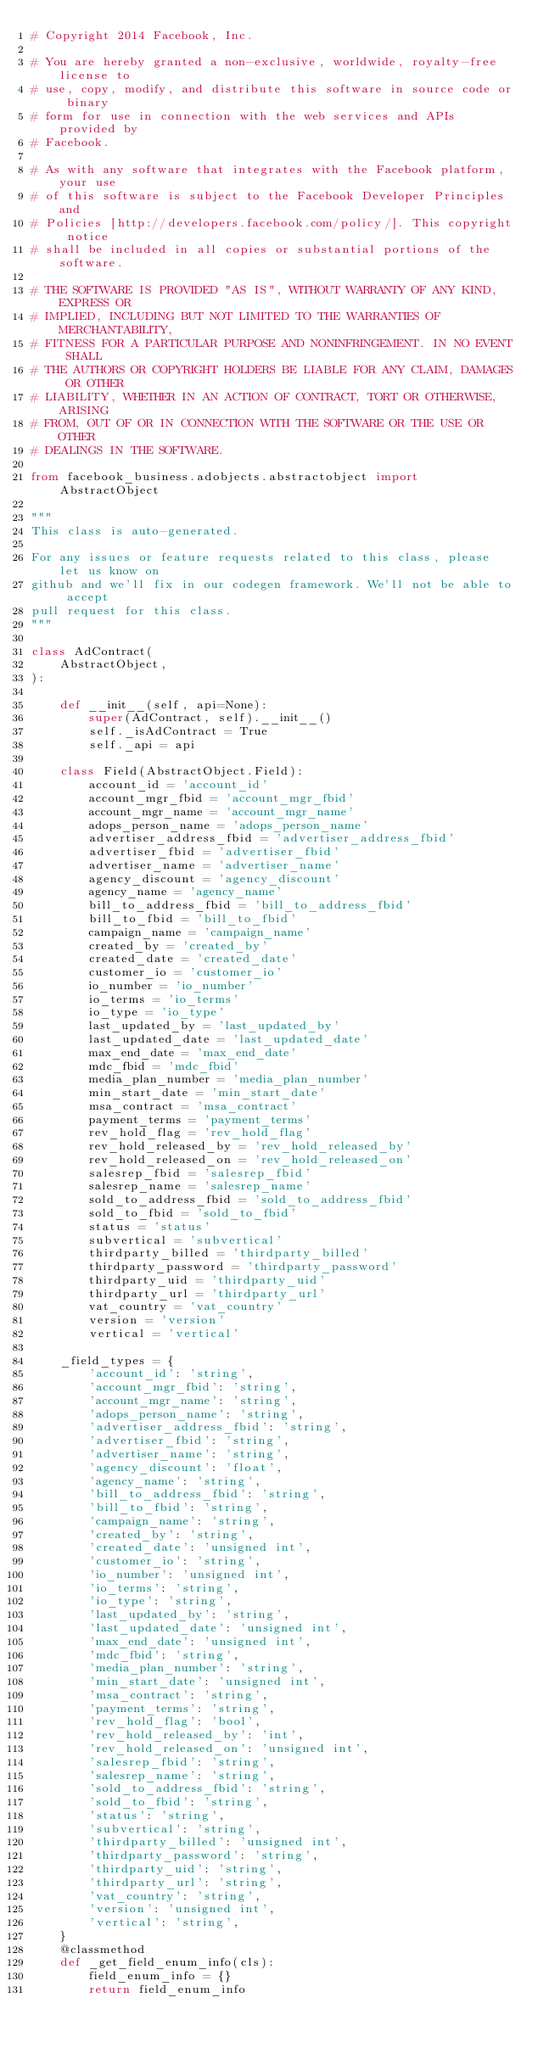Convert code to text. <code><loc_0><loc_0><loc_500><loc_500><_Python_># Copyright 2014 Facebook, Inc.

# You are hereby granted a non-exclusive, worldwide, royalty-free license to
# use, copy, modify, and distribute this software in source code or binary
# form for use in connection with the web services and APIs provided by
# Facebook.

# As with any software that integrates with the Facebook platform, your use
# of this software is subject to the Facebook Developer Principles and
# Policies [http://developers.facebook.com/policy/]. This copyright notice
# shall be included in all copies or substantial portions of the software.

# THE SOFTWARE IS PROVIDED "AS IS", WITHOUT WARRANTY OF ANY KIND, EXPRESS OR
# IMPLIED, INCLUDING BUT NOT LIMITED TO THE WARRANTIES OF MERCHANTABILITY,
# FITNESS FOR A PARTICULAR PURPOSE AND NONINFRINGEMENT. IN NO EVENT SHALL
# THE AUTHORS OR COPYRIGHT HOLDERS BE LIABLE FOR ANY CLAIM, DAMAGES OR OTHER
# LIABILITY, WHETHER IN AN ACTION OF CONTRACT, TORT OR OTHERWISE, ARISING
# FROM, OUT OF OR IN CONNECTION WITH THE SOFTWARE OR THE USE OR OTHER
# DEALINGS IN THE SOFTWARE.

from facebook_business.adobjects.abstractobject import AbstractObject

"""
This class is auto-generated.

For any issues or feature requests related to this class, please let us know on
github and we'll fix in our codegen framework. We'll not be able to accept
pull request for this class.
"""

class AdContract(
    AbstractObject,
):

    def __init__(self, api=None):
        super(AdContract, self).__init__()
        self._isAdContract = True
        self._api = api

    class Field(AbstractObject.Field):
        account_id = 'account_id'
        account_mgr_fbid = 'account_mgr_fbid'
        account_mgr_name = 'account_mgr_name'
        adops_person_name = 'adops_person_name'
        advertiser_address_fbid = 'advertiser_address_fbid'
        advertiser_fbid = 'advertiser_fbid'
        advertiser_name = 'advertiser_name'
        agency_discount = 'agency_discount'
        agency_name = 'agency_name'
        bill_to_address_fbid = 'bill_to_address_fbid'
        bill_to_fbid = 'bill_to_fbid'
        campaign_name = 'campaign_name'
        created_by = 'created_by'
        created_date = 'created_date'
        customer_io = 'customer_io'
        io_number = 'io_number'
        io_terms = 'io_terms'
        io_type = 'io_type'
        last_updated_by = 'last_updated_by'
        last_updated_date = 'last_updated_date'
        max_end_date = 'max_end_date'
        mdc_fbid = 'mdc_fbid'
        media_plan_number = 'media_plan_number'
        min_start_date = 'min_start_date'
        msa_contract = 'msa_contract'
        payment_terms = 'payment_terms'
        rev_hold_flag = 'rev_hold_flag'
        rev_hold_released_by = 'rev_hold_released_by'
        rev_hold_released_on = 'rev_hold_released_on'
        salesrep_fbid = 'salesrep_fbid'
        salesrep_name = 'salesrep_name'
        sold_to_address_fbid = 'sold_to_address_fbid'
        sold_to_fbid = 'sold_to_fbid'
        status = 'status'
        subvertical = 'subvertical'
        thirdparty_billed = 'thirdparty_billed'
        thirdparty_password = 'thirdparty_password'
        thirdparty_uid = 'thirdparty_uid'
        thirdparty_url = 'thirdparty_url'
        vat_country = 'vat_country'
        version = 'version'
        vertical = 'vertical'

    _field_types = {
        'account_id': 'string',
        'account_mgr_fbid': 'string',
        'account_mgr_name': 'string',
        'adops_person_name': 'string',
        'advertiser_address_fbid': 'string',
        'advertiser_fbid': 'string',
        'advertiser_name': 'string',
        'agency_discount': 'float',
        'agency_name': 'string',
        'bill_to_address_fbid': 'string',
        'bill_to_fbid': 'string',
        'campaign_name': 'string',
        'created_by': 'string',
        'created_date': 'unsigned int',
        'customer_io': 'string',
        'io_number': 'unsigned int',
        'io_terms': 'string',
        'io_type': 'string',
        'last_updated_by': 'string',
        'last_updated_date': 'unsigned int',
        'max_end_date': 'unsigned int',
        'mdc_fbid': 'string',
        'media_plan_number': 'string',
        'min_start_date': 'unsigned int',
        'msa_contract': 'string',
        'payment_terms': 'string',
        'rev_hold_flag': 'bool',
        'rev_hold_released_by': 'int',
        'rev_hold_released_on': 'unsigned int',
        'salesrep_fbid': 'string',
        'salesrep_name': 'string',
        'sold_to_address_fbid': 'string',
        'sold_to_fbid': 'string',
        'status': 'string',
        'subvertical': 'string',
        'thirdparty_billed': 'unsigned int',
        'thirdparty_password': 'string',
        'thirdparty_uid': 'string',
        'thirdparty_url': 'string',
        'vat_country': 'string',
        'version': 'unsigned int',
        'vertical': 'string',
    }
    @classmethod
    def _get_field_enum_info(cls):
        field_enum_info = {}
        return field_enum_info


</code> 